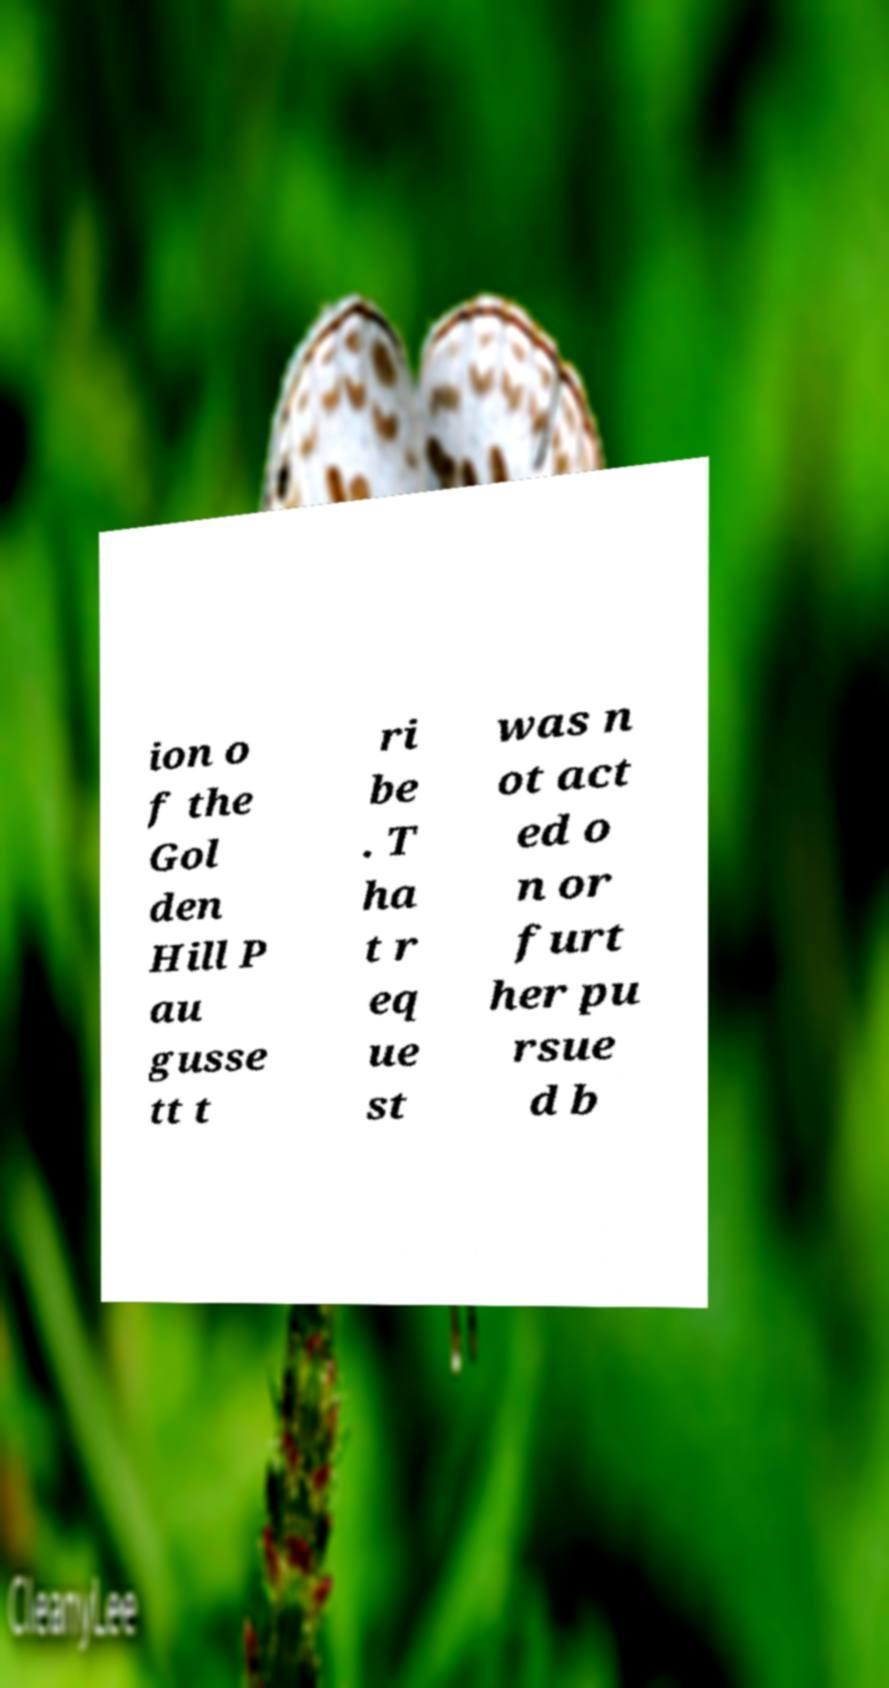What messages or text are displayed in this image? I need them in a readable, typed format. ion o f the Gol den Hill P au gusse tt t ri be . T ha t r eq ue st was n ot act ed o n or furt her pu rsue d b 